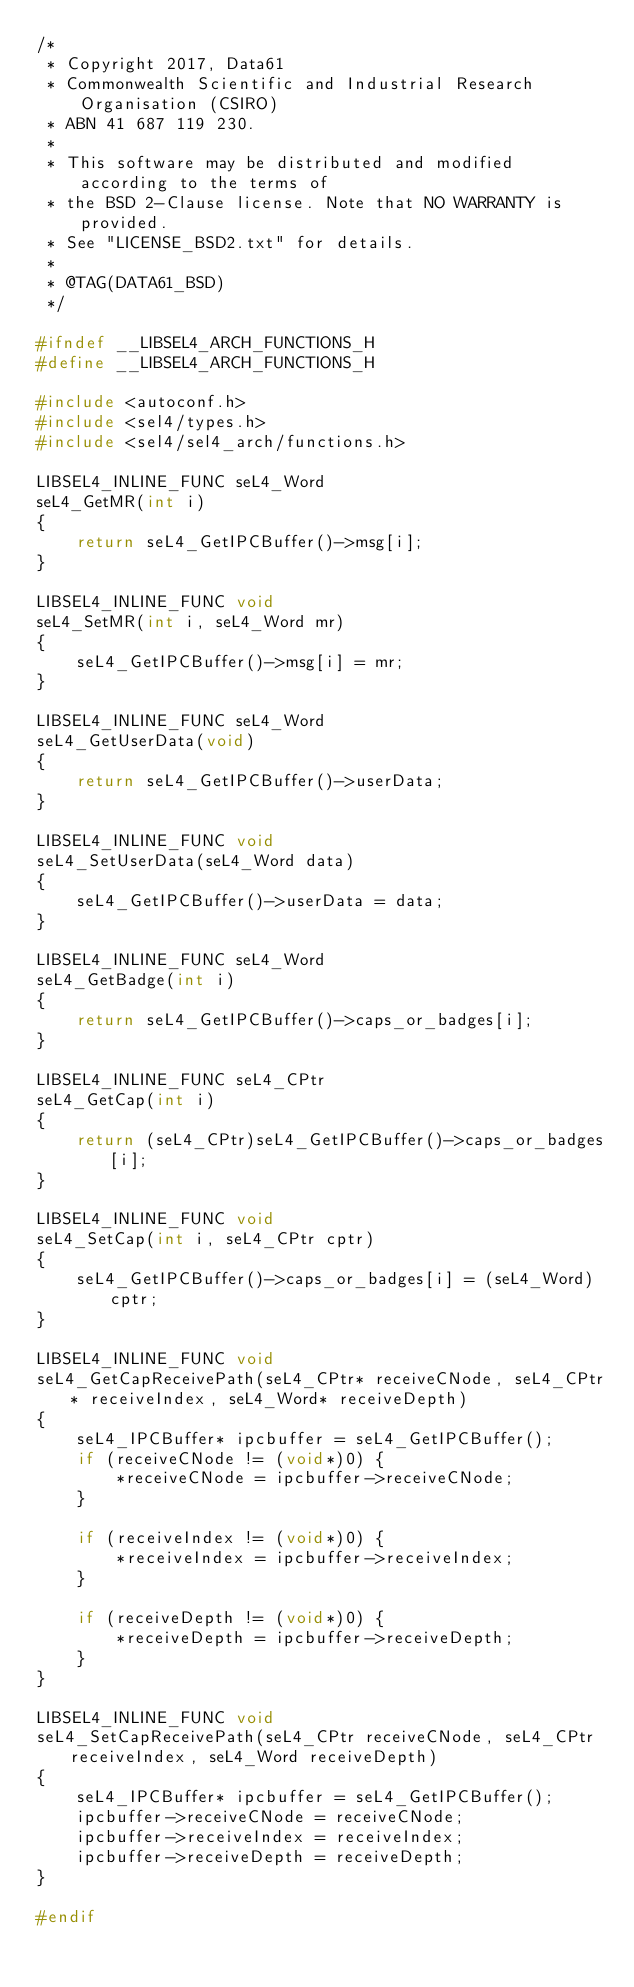Convert code to text. <code><loc_0><loc_0><loc_500><loc_500><_C_>/*
 * Copyright 2017, Data61
 * Commonwealth Scientific and Industrial Research Organisation (CSIRO)
 * ABN 41 687 119 230.
 *
 * This software may be distributed and modified according to the terms of
 * the BSD 2-Clause license. Note that NO WARRANTY is provided.
 * See "LICENSE_BSD2.txt" for details.
 *
 * @TAG(DATA61_BSD)
 */

#ifndef __LIBSEL4_ARCH_FUNCTIONS_H
#define __LIBSEL4_ARCH_FUNCTIONS_H

#include <autoconf.h>
#include <sel4/types.h>
#include <sel4/sel4_arch/functions.h>

LIBSEL4_INLINE_FUNC seL4_Word
seL4_GetMR(int i)
{
    return seL4_GetIPCBuffer()->msg[i];
}

LIBSEL4_INLINE_FUNC void
seL4_SetMR(int i, seL4_Word mr)
{
    seL4_GetIPCBuffer()->msg[i] = mr;
}

LIBSEL4_INLINE_FUNC seL4_Word
seL4_GetUserData(void)
{
    return seL4_GetIPCBuffer()->userData;
}

LIBSEL4_INLINE_FUNC void
seL4_SetUserData(seL4_Word data)
{
    seL4_GetIPCBuffer()->userData = data;
}

LIBSEL4_INLINE_FUNC seL4_Word
seL4_GetBadge(int i)
{
    return seL4_GetIPCBuffer()->caps_or_badges[i];
}

LIBSEL4_INLINE_FUNC seL4_CPtr
seL4_GetCap(int i)
{
    return (seL4_CPtr)seL4_GetIPCBuffer()->caps_or_badges[i];
}

LIBSEL4_INLINE_FUNC void
seL4_SetCap(int i, seL4_CPtr cptr)
{
    seL4_GetIPCBuffer()->caps_or_badges[i] = (seL4_Word)cptr;
}

LIBSEL4_INLINE_FUNC void
seL4_GetCapReceivePath(seL4_CPtr* receiveCNode, seL4_CPtr* receiveIndex, seL4_Word* receiveDepth)
{
    seL4_IPCBuffer* ipcbuffer = seL4_GetIPCBuffer();
    if (receiveCNode != (void*)0) {
        *receiveCNode = ipcbuffer->receiveCNode;
    }

    if (receiveIndex != (void*)0) {
        *receiveIndex = ipcbuffer->receiveIndex;
    }

    if (receiveDepth != (void*)0) {
        *receiveDepth = ipcbuffer->receiveDepth;
    }
}

LIBSEL4_INLINE_FUNC void
seL4_SetCapReceivePath(seL4_CPtr receiveCNode, seL4_CPtr receiveIndex, seL4_Word receiveDepth)
{
    seL4_IPCBuffer* ipcbuffer = seL4_GetIPCBuffer();
    ipcbuffer->receiveCNode = receiveCNode;
    ipcbuffer->receiveIndex = receiveIndex;
    ipcbuffer->receiveDepth = receiveDepth;
}

#endif
</code> 